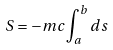Convert formula to latex. <formula><loc_0><loc_0><loc_500><loc_500>S = - m c \int _ { a } ^ { b } d s</formula> 